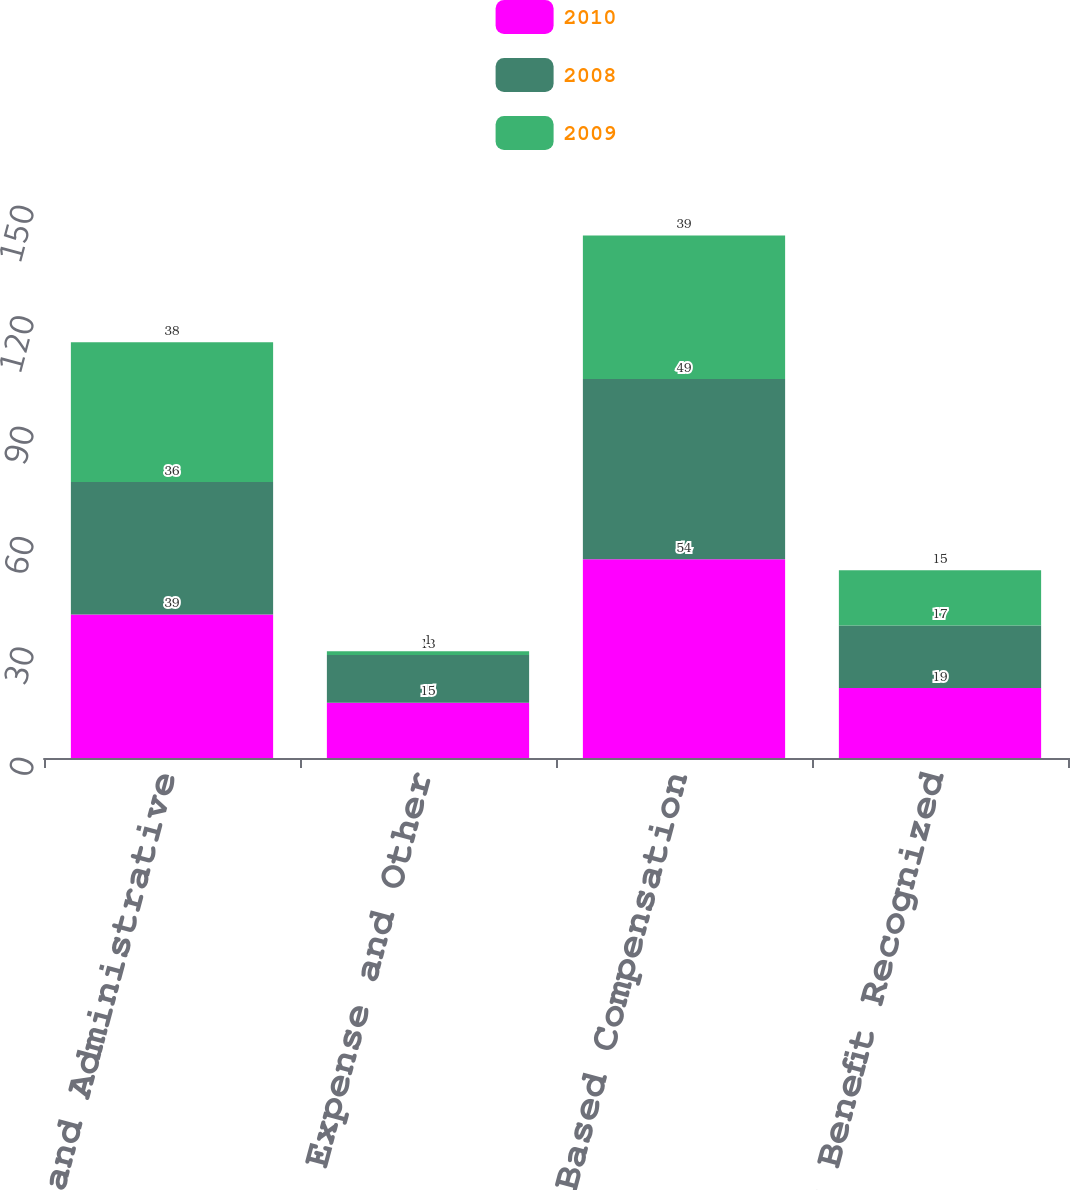<chart> <loc_0><loc_0><loc_500><loc_500><stacked_bar_chart><ecel><fcel>General and Administrative<fcel>Exploration Expense and Other<fcel>Total Stock-Based Compensation<fcel>Tax Benefit Recognized<nl><fcel>2010<fcel>39<fcel>15<fcel>54<fcel>19<nl><fcel>2008<fcel>36<fcel>13<fcel>49<fcel>17<nl><fcel>2009<fcel>38<fcel>1<fcel>39<fcel>15<nl></chart> 